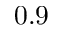Convert formula to latex. <formula><loc_0><loc_0><loc_500><loc_500>0 . 9</formula> 